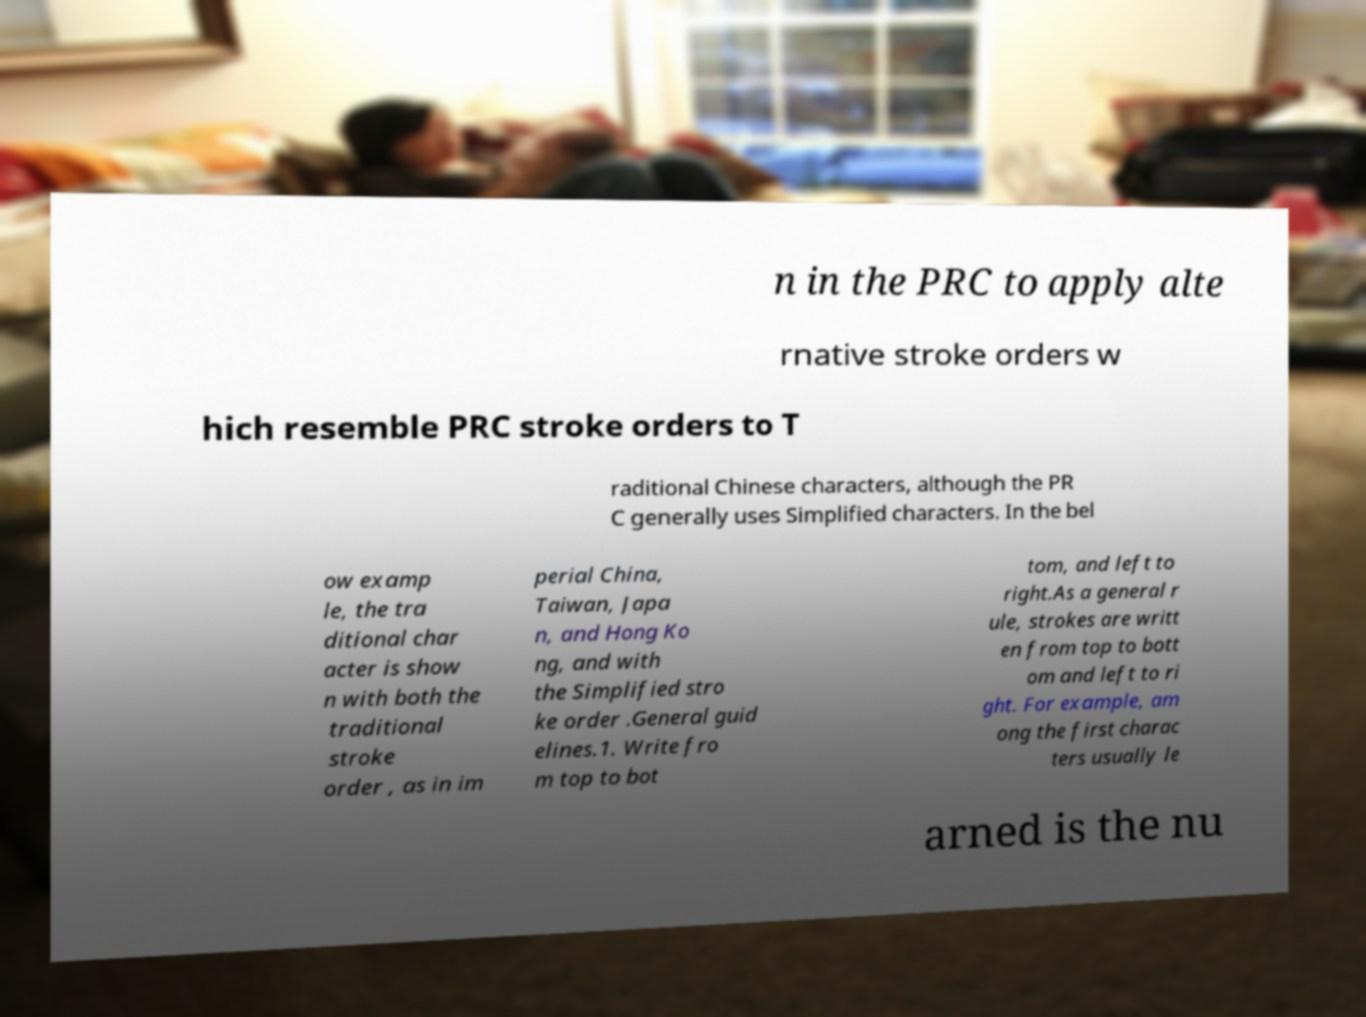There's text embedded in this image that I need extracted. Can you transcribe it verbatim? n in the PRC to apply alte rnative stroke orders w hich resemble PRC stroke orders to T raditional Chinese characters, although the PR C generally uses Simplified characters. In the bel ow examp le, the tra ditional char acter is show n with both the traditional stroke order , as in im perial China, Taiwan, Japa n, and Hong Ko ng, and with the Simplified stro ke order .General guid elines.1. Write fro m top to bot tom, and left to right.As a general r ule, strokes are writt en from top to bott om and left to ri ght. For example, am ong the first charac ters usually le arned is the nu 